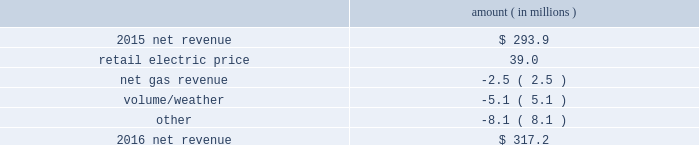Entergy new orleans , inc .
And subsidiaries management 2019s financial discussion and analysis results of operations net income 2016 compared to 2015 net income increased $ 3.9 million primarily due to higher net revenue , partially offset by higher depreciation and amortization expenses , higher interest expense , and lower other income .
2015 compared to 2014 net income increased $ 13.9 million primarily due to lower other operation and maintenance expenses and higher net revenue , partially offset by a higher effective income tax rate .
Net revenue 2016 compared to 2015 net revenue consists of operating revenues net of : 1 ) fuel , fuel-related expenses , and gas purchased for resale , 2 ) purchased power expenses , and 3 ) other regulatory charges .
Following is an analysis of the change in net revenue comparing 2016 to 2015 .
Amount ( in millions ) .
The retail electric price variance is primarily due to an increase in the purchased power and capacity acquisition cost recovery rider , as approved by the city council , effective with the first billing cycle of march 2016 , primarily related to the purchase of power block 1 of the union power station .
See note 14 to the financial statements for discussion of the union power station purchase .
The net gas revenue variance is primarily due to the effect of less favorable weather on residential and commercial sales .
The volume/weather variance is primarily due to a decrease of 112 gwh , or 2% ( 2 % ) , in billed electricity usage , partially offset by the effect of favorable weather on commercial sales and a 2% ( 2 % ) increase in the average number of electric customers. .
What is the net change in net revenue during 2016 for entergy new orleans , inc? 
Computations: (317.2 - 293.9)
Answer: 23.3. 